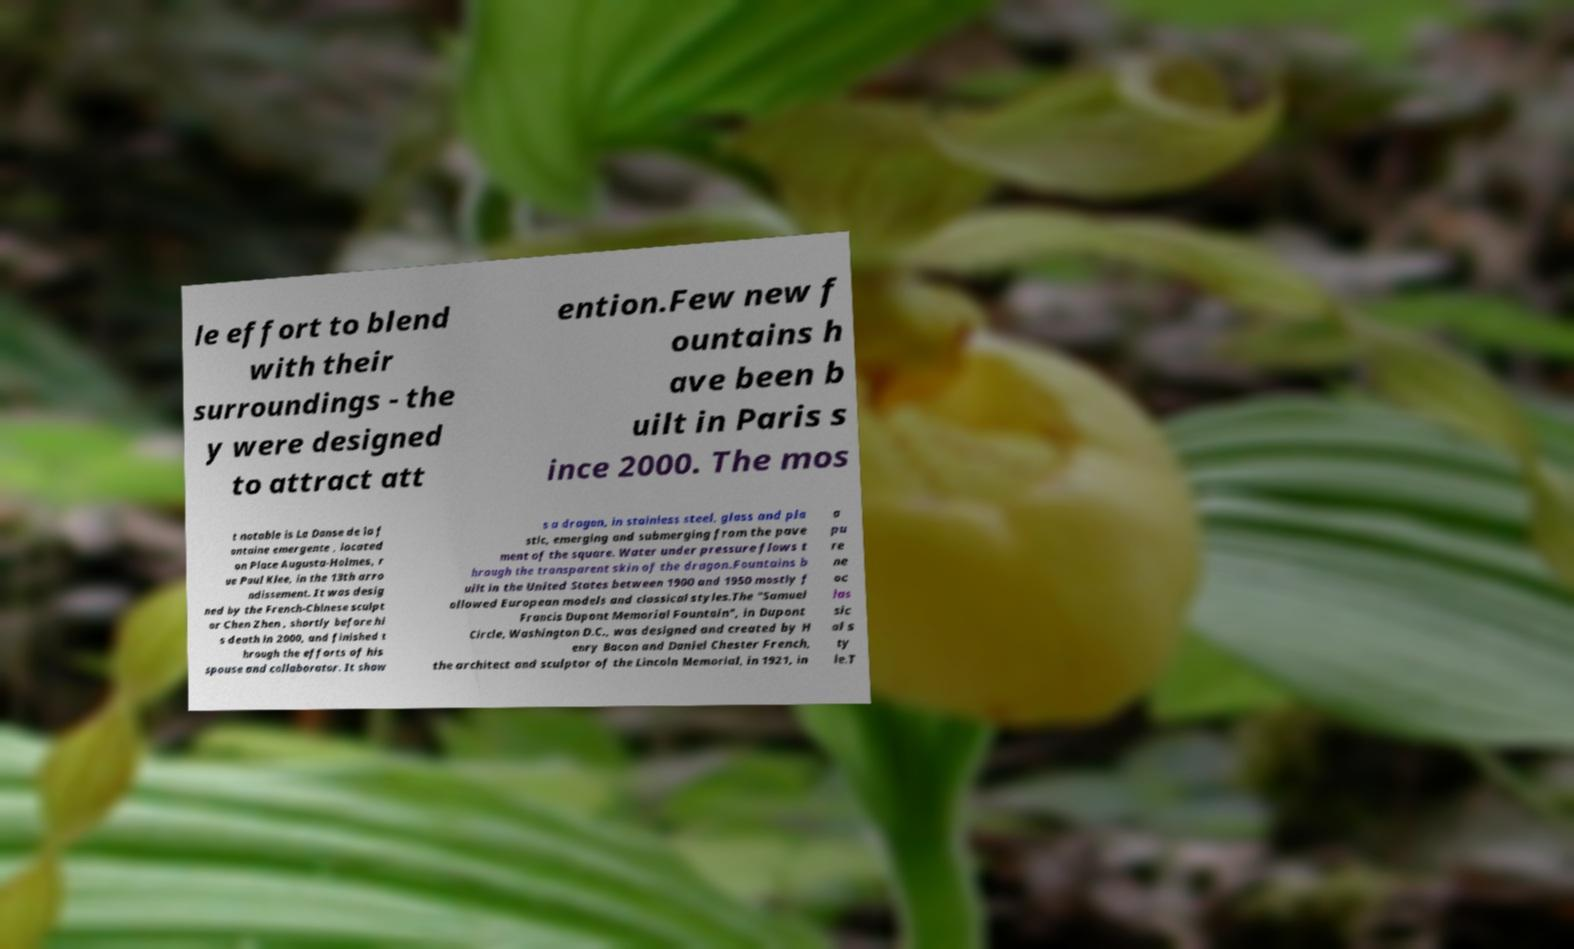For documentation purposes, I need the text within this image transcribed. Could you provide that? le effort to blend with their surroundings - the y were designed to attract att ention.Few new f ountains h ave been b uilt in Paris s ince 2000. The mos t notable is La Danse de la f ontaine emergente , located on Place Augusta-Holmes, r ue Paul Klee, in the 13th arro ndissement. It was desig ned by the French-Chinese sculpt or Chen Zhen , shortly before hi s death in 2000, and finished t hrough the efforts of his spouse and collaborator. It show s a dragon, in stainless steel, glass and pla stic, emerging and submerging from the pave ment of the square. Water under pressure flows t hrough the transparent skin of the dragon.Fountains b uilt in the United States between 1900 and 1950 mostly f ollowed European models and classical styles.The "Samuel Francis Dupont Memorial Fountain", in Dupont Circle, Washington D.C., was designed and created by H enry Bacon and Daniel Chester French, the architect and sculptor of the Lincoln Memorial, in 1921, in a pu re ne oc las sic al s ty le.T 